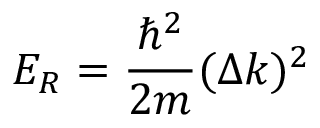Convert formula to latex. <formula><loc_0><loc_0><loc_500><loc_500>E _ { R } = \frac { \hbar { ^ } { 2 } } { 2 m } ( \Delta k ) ^ { 2 }</formula> 